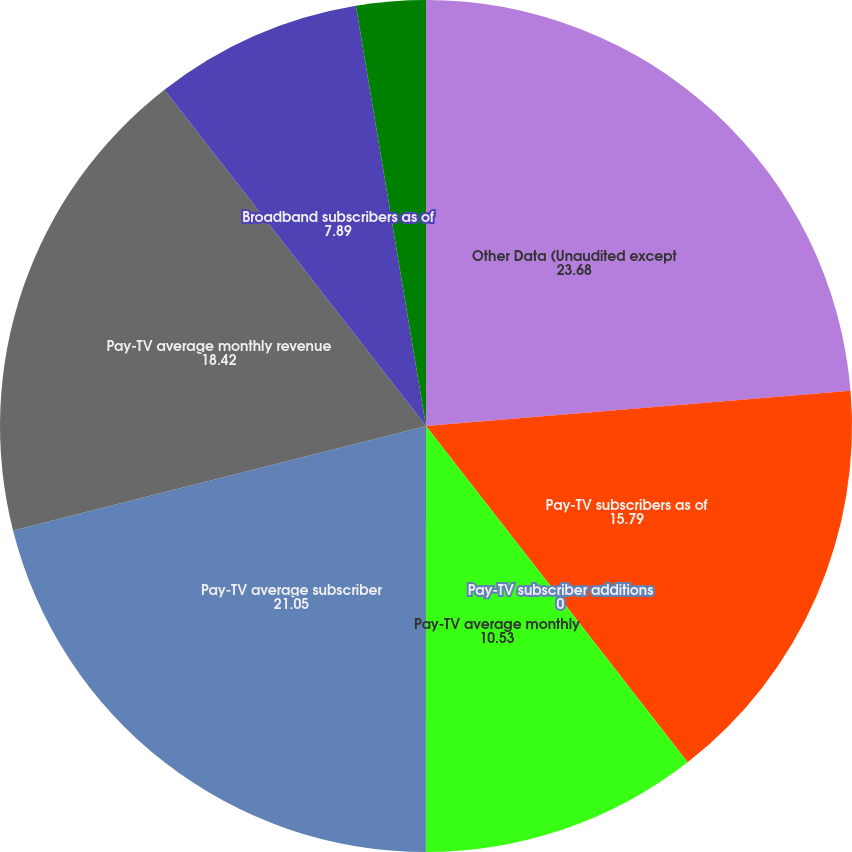Convert chart. <chart><loc_0><loc_0><loc_500><loc_500><pie_chart><fcel>Other Data (Unaudited except<fcel>Pay-TV subscribers as of<fcel>Pay-TV subscriber additions<fcel>Pay-TV average monthly<fcel>Pay-TV average subscriber<fcel>Pay-TV average monthly revenue<fcel>Broadband subscribers as of<fcel>Broadband subscriber additions<nl><fcel>23.68%<fcel>15.79%<fcel>0.0%<fcel>10.53%<fcel>21.05%<fcel>18.42%<fcel>7.89%<fcel>2.63%<nl></chart> 